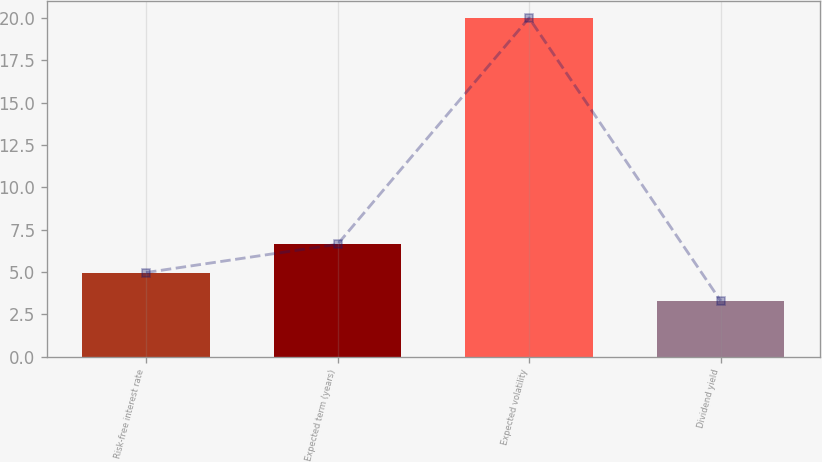<chart> <loc_0><loc_0><loc_500><loc_500><bar_chart><fcel>Risk-free interest rate<fcel>Expected term (years)<fcel>Expected volatility<fcel>Dividend yield<nl><fcel>4.97<fcel>6.64<fcel>20<fcel>3.3<nl></chart> 